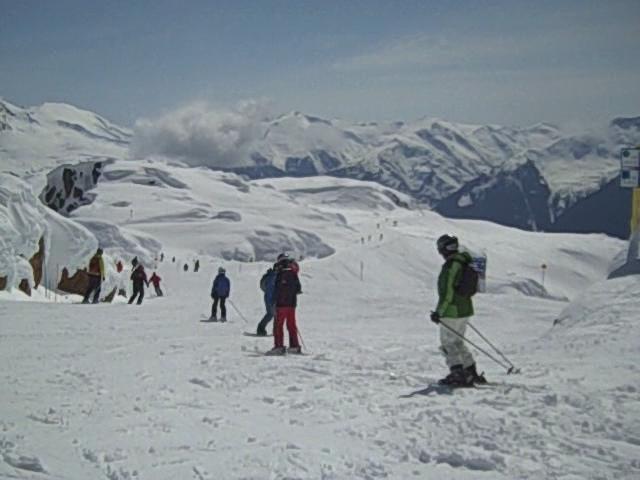What season brings this weather?
Indicate the correct response and explain using: 'Answer: answer
Rationale: rationale.'
Options: Winter, summer, fall, spring. Answer: winter.
Rationale: The ground is covered in snow. 